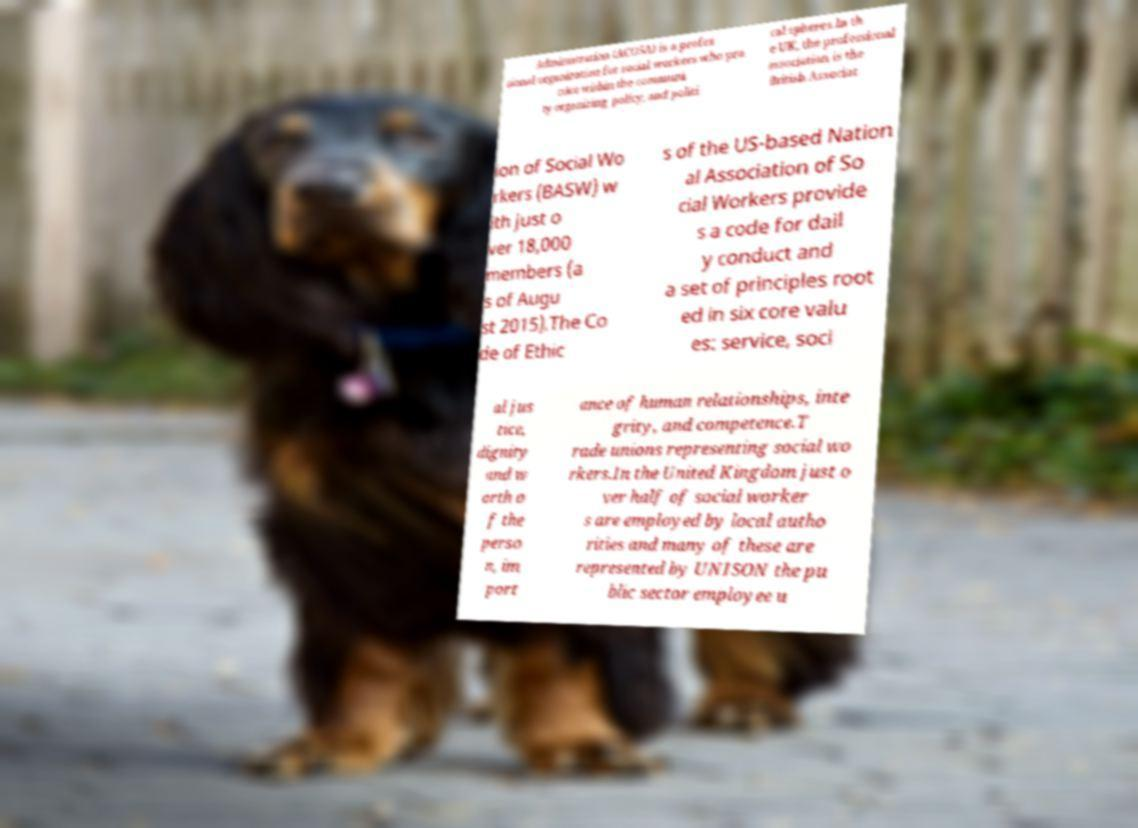For documentation purposes, I need the text within this image transcribed. Could you provide that? Administration (ACOSA) is a profes sional organization for social workers who pra ctice within the communi ty organizing, policy, and politi cal spheres.In th e UK, the professional association is the British Associat ion of Social Wo rkers (BASW) w ith just o ver 18,000 members (a s of Augu st 2015).The Co de of Ethic s of the US-based Nation al Association of So cial Workers provide s a code for dail y conduct and a set of principles root ed in six core valu es: service, soci al jus tice, dignity and w orth o f the perso n, im port ance of human relationships, inte grity, and competence.T rade unions representing social wo rkers.In the United Kingdom just o ver half of social worker s are employed by local autho rities and many of these are represented by UNISON the pu blic sector employee u 